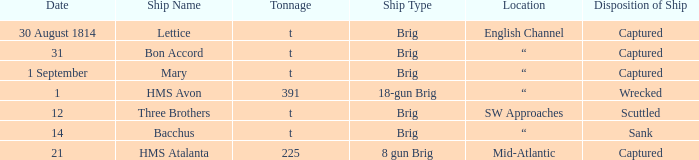What date was a brig type ship located in SW Approaches? 12.0. 